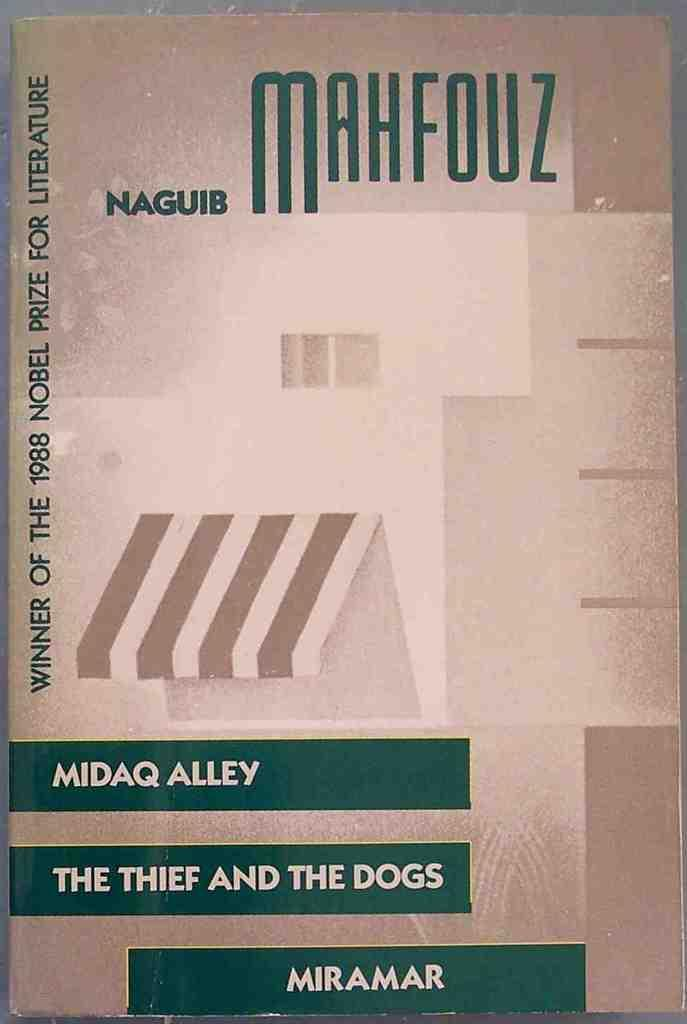<image>
Render a clear and concise summary of the photo. cover of Naguib Mahfouz book about Midaq Alley and the Thief and the dogs 